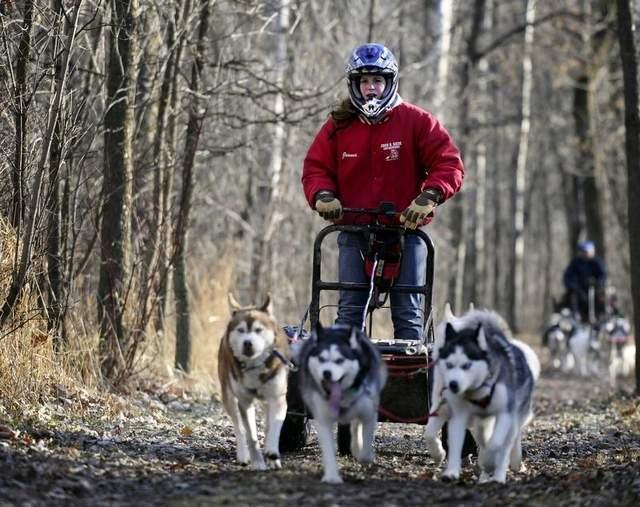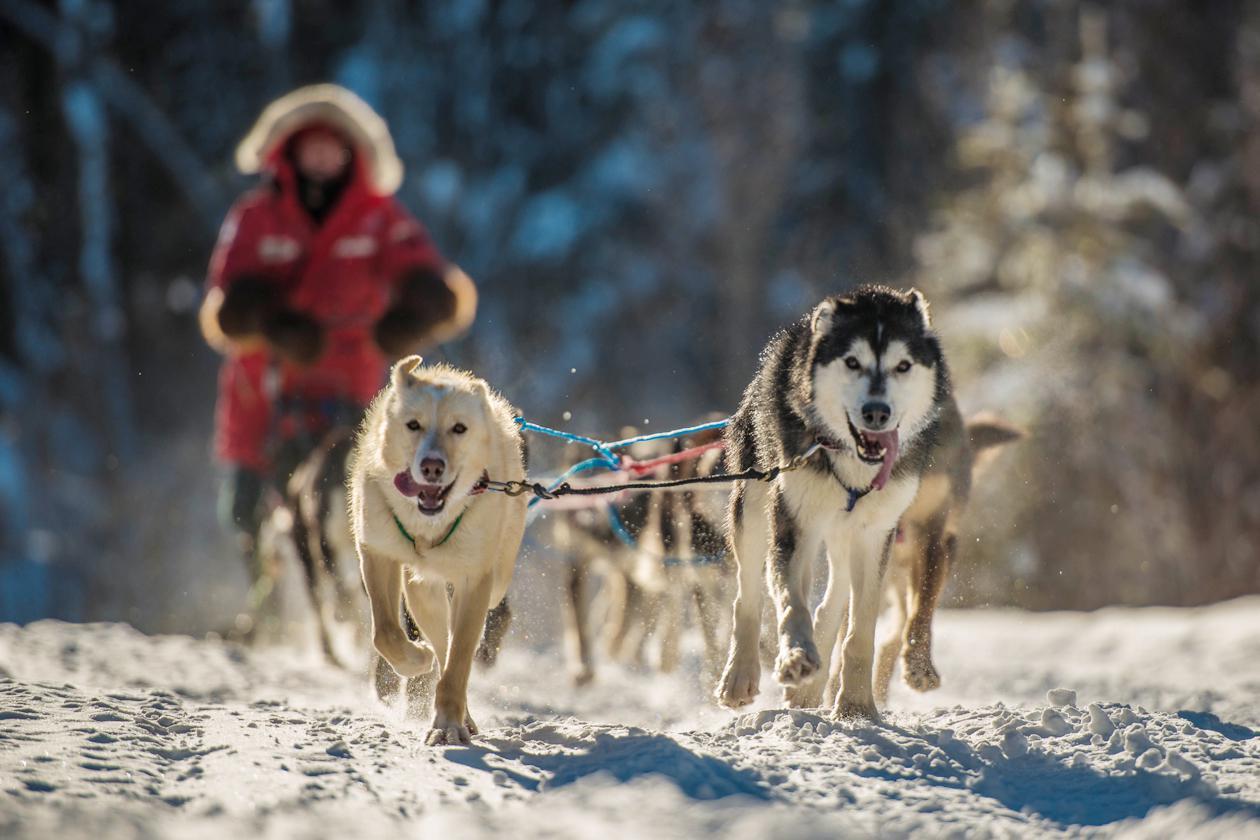The first image is the image on the left, the second image is the image on the right. Assess this claim about the two images: "Right image shows a team of dogs moving over snowy ground toward the camera.". Correct or not? Answer yes or no. Yes. The first image is the image on the left, the second image is the image on the right. Assess this claim about the two images: "The sled rider in the image on the left is wearing a white vest with a number.". Correct or not? Answer yes or no. No. 